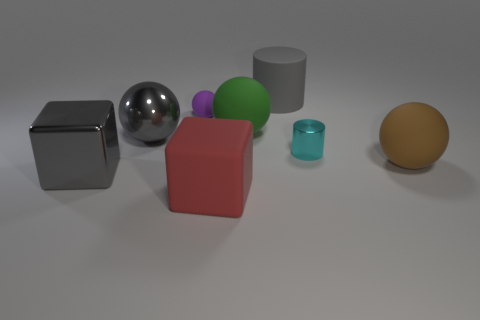There is a big object that is both in front of the brown rubber sphere and right of the gray block; what material is it?
Provide a short and direct response. Rubber. The green object that is made of the same material as the large cylinder is what shape?
Offer a very short reply. Sphere. The green object that is made of the same material as the big brown object is what size?
Your response must be concise. Large. The gray object that is behind the large brown matte sphere and left of the tiny rubber ball has what shape?
Your response must be concise. Sphere. How big is the purple sphere that is behind the cylinder in front of the purple sphere?
Provide a succinct answer. Small. What number of other things are the same color as the large metal block?
Offer a very short reply. 2. What is the big gray ball made of?
Provide a succinct answer. Metal. Are any tiny cyan matte cubes visible?
Your answer should be compact. No. Are there an equal number of large green matte balls on the left side of the gray rubber object and purple shiny balls?
Your answer should be compact. No. What number of small things are red objects or cyan matte objects?
Your response must be concise. 0. 